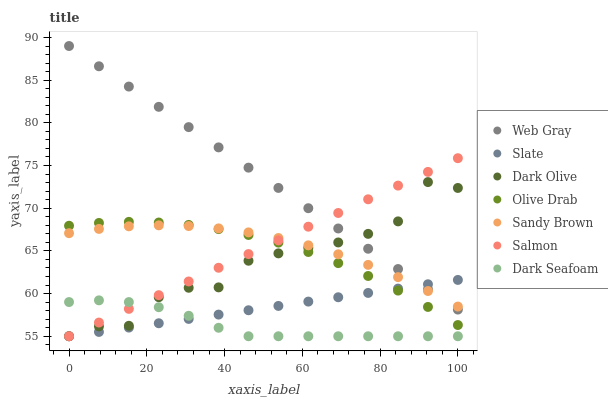Does Dark Seafoam have the minimum area under the curve?
Answer yes or no. Yes. Does Web Gray have the maximum area under the curve?
Answer yes or no. Yes. Does Slate have the minimum area under the curve?
Answer yes or no. No. Does Slate have the maximum area under the curve?
Answer yes or no. No. Is Salmon the smoothest?
Answer yes or no. Yes. Is Dark Olive the roughest?
Answer yes or no. Yes. Is Slate the smoothest?
Answer yes or no. No. Is Slate the roughest?
Answer yes or no. No. Does Slate have the lowest value?
Answer yes or no. Yes. Does Sandy Brown have the lowest value?
Answer yes or no. No. Does Web Gray have the highest value?
Answer yes or no. Yes. Does Slate have the highest value?
Answer yes or no. No. Is Dark Seafoam less than Olive Drab?
Answer yes or no. Yes. Is Olive Drab greater than Dark Seafoam?
Answer yes or no. Yes. Does Slate intersect Web Gray?
Answer yes or no. Yes. Is Slate less than Web Gray?
Answer yes or no. No. Is Slate greater than Web Gray?
Answer yes or no. No. Does Dark Seafoam intersect Olive Drab?
Answer yes or no. No. 